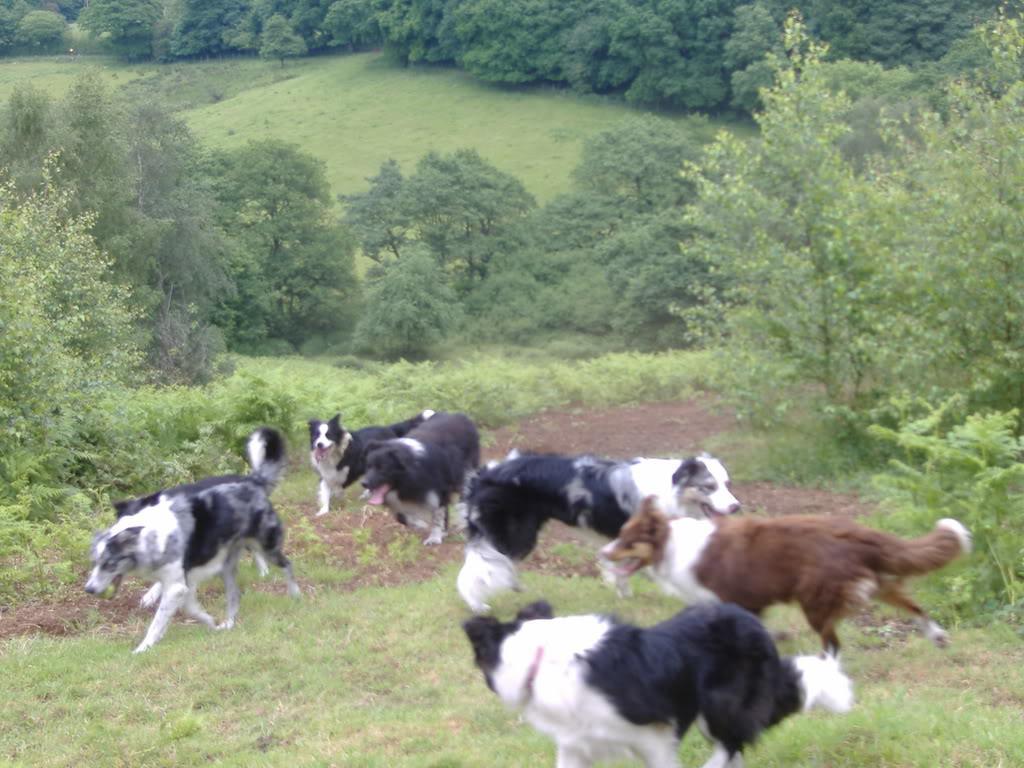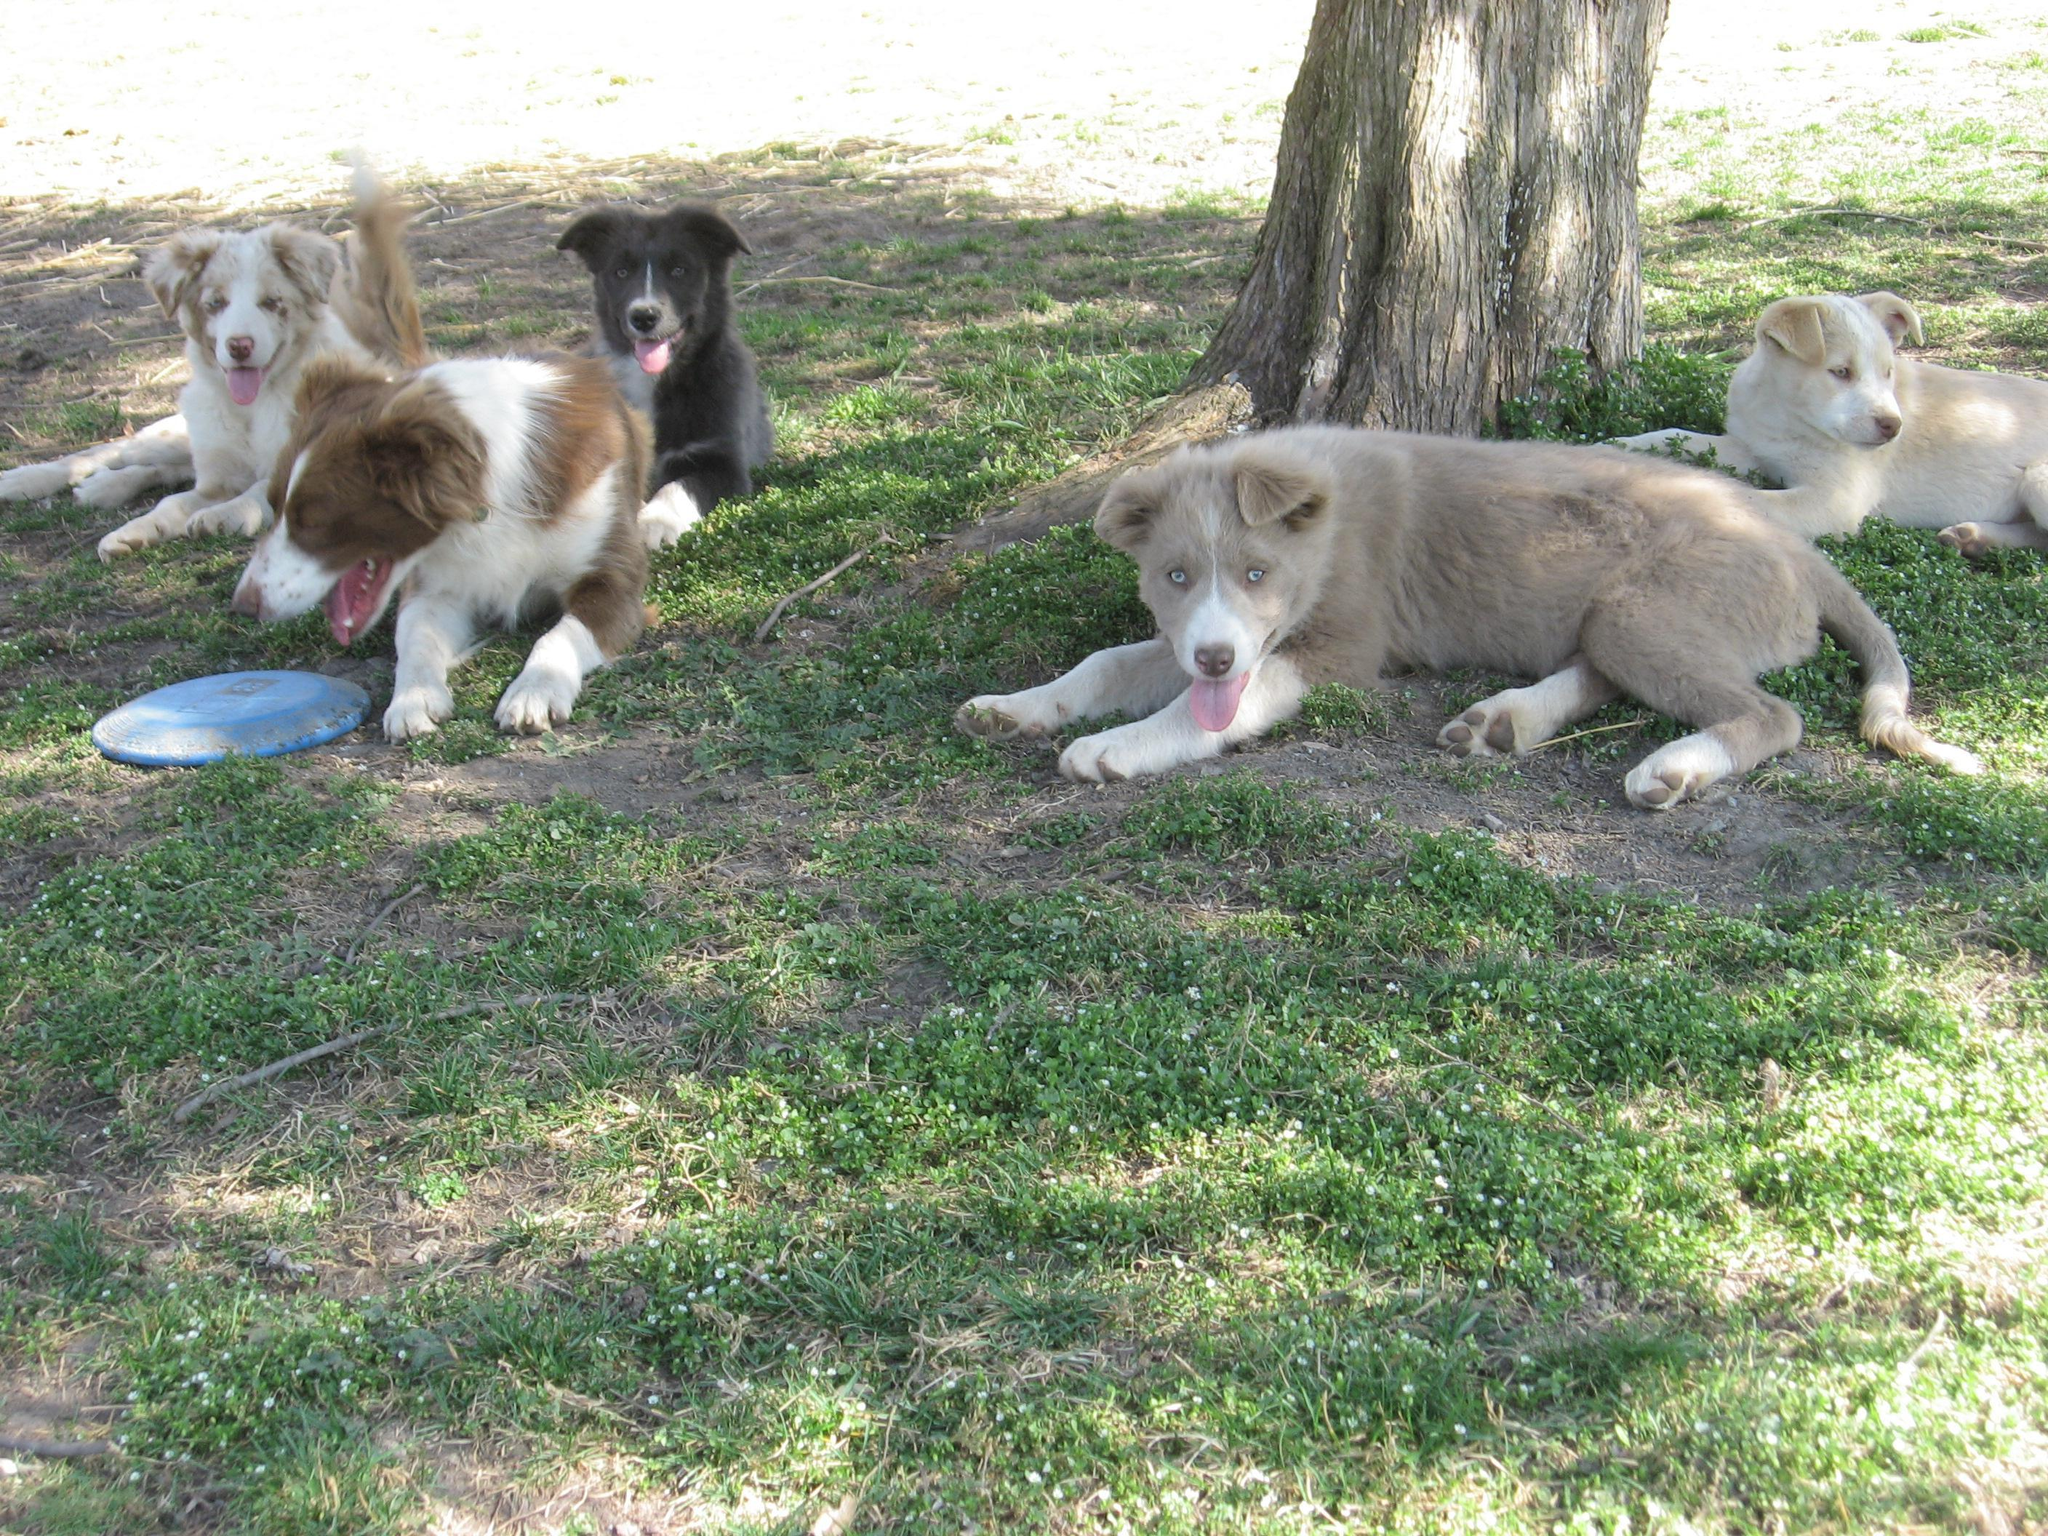The first image is the image on the left, the second image is the image on the right. Analyze the images presented: Is the assertion "An image shows a nozzle spraying water at a group of black-and-white dogs." valid? Answer yes or no. No. The first image is the image on the left, the second image is the image on the right. Assess this claim about the two images: "There are at least half a dozen dogs lying in a line on the grass in one of the images.". Correct or not? Answer yes or no. No. 